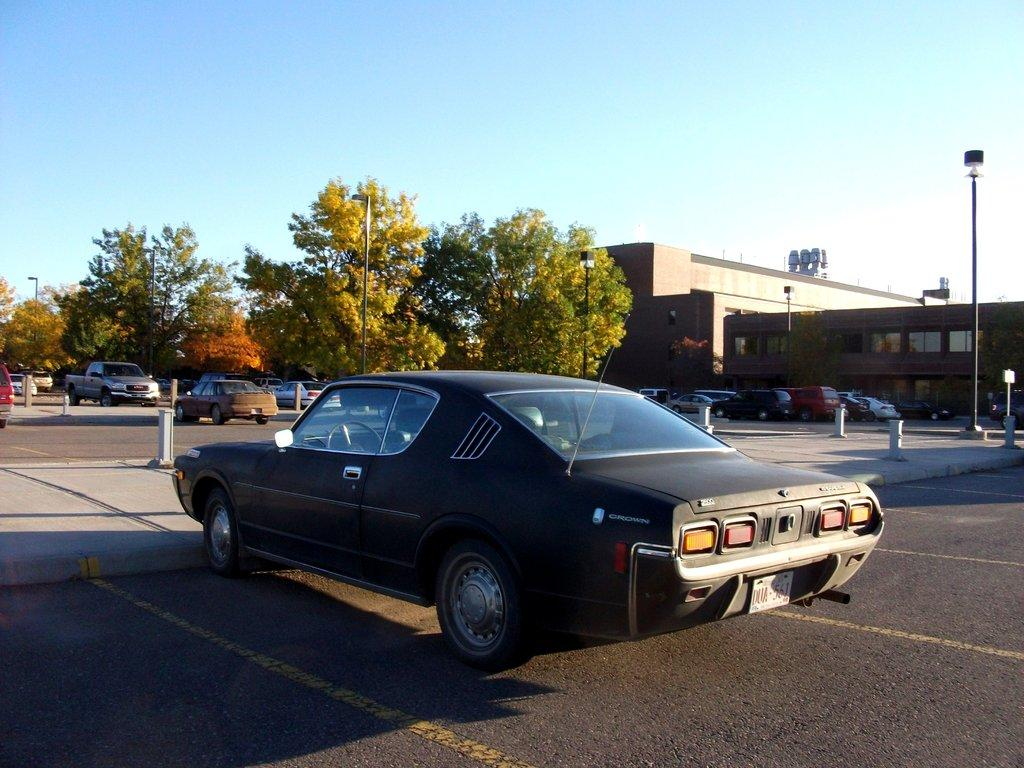What type of vehicles can be seen in the image? There are cars in the image. What structures are present in the image? There are buildings in the image. What type of vegetation is visible in the image? There are trees in the image. What object is standing upright in the image? There is a pole in the image. What part of the natural environment is visible in the image? The sky is visible in the image. What type of property is being sold in the image? There is no indication of any property being sold in the image. What type of skirt is being worn by the trees in the image? There are no skirts present in the image, as trees do not wear clothing. 